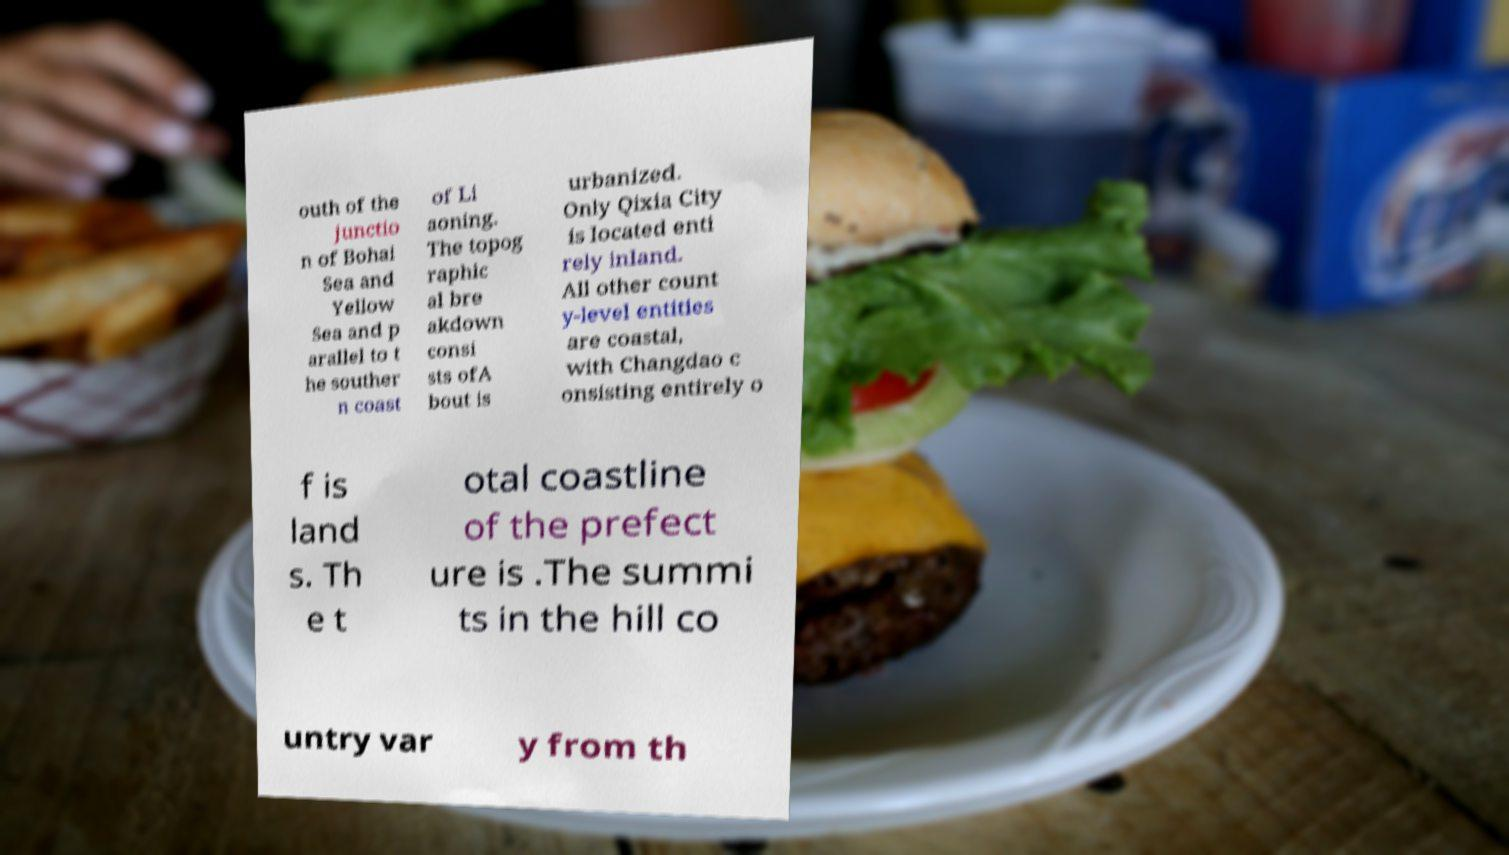Please read and relay the text visible in this image. What does it say? outh of the junctio n of Bohai Sea and Yellow Sea and p arallel to t he souther n coast of Li aoning. The topog raphic al bre akdown consi sts ofA bout is urbanized. Only Qixia City is located enti rely inland. All other count y-level entities are coastal, with Changdao c onsisting entirely o f is land s. Th e t otal coastline of the prefect ure is .The summi ts in the hill co untry var y from th 